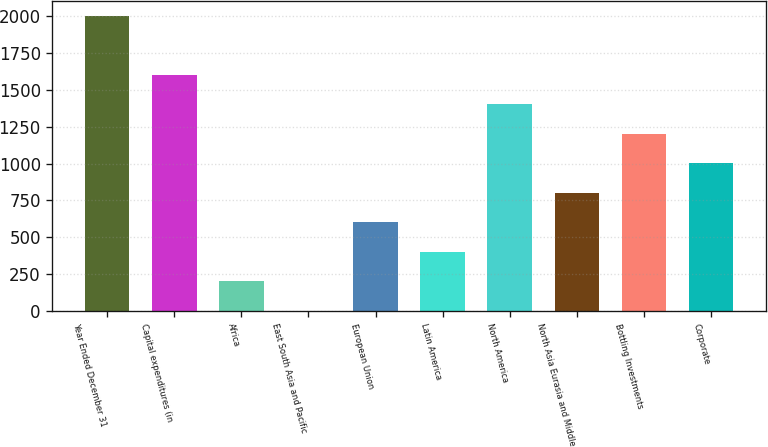<chart> <loc_0><loc_0><loc_500><loc_500><bar_chart><fcel>Year Ended December 31<fcel>Capital expenditures (in<fcel>Africa<fcel>East South Asia and Pacific<fcel>European Union<fcel>Latin America<fcel>North America<fcel>North Asia Eurasia and Middle<fcel>Bottling Investments<fcel>Corporate<nl><fcel>2006<fcel>1604.94<fcel>201.23<fcel>0.7<fcel>602.29<fcel>401.76<fcel>1404.41<fcel>802.82<fcel>1203.88<fcel>1003.35<nl></chart> 